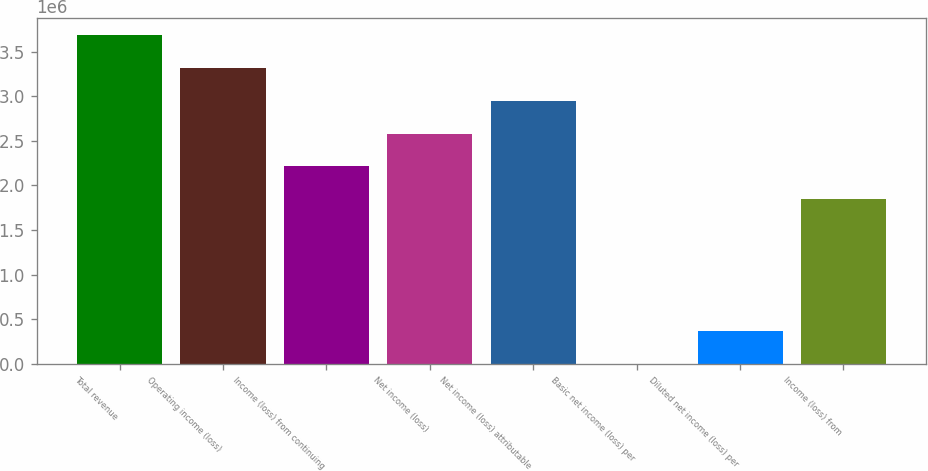Convert chart. <chart><loc_0><loc_0><loc_500><loc_500><bar_chart><fcel>Total revenue<fcel>Operating income (loss)<fcel>Income (loss) from continuing<fcel>Net income (loss)<fcel>Net income (loss) attributable<fcel>Basic net income (loss) per<fcel>Diluted net income (loss) per<fcel>Income (loss) from<nl><fcel>3.68812e+06<fcel>3.31931e+06<fcel>2.21287e+06<fcel>2.58168e+06<fcel>2.9505e+06<fcel>0.01<fcel>368812<fcel>1.84406e+06<nl></chart> 